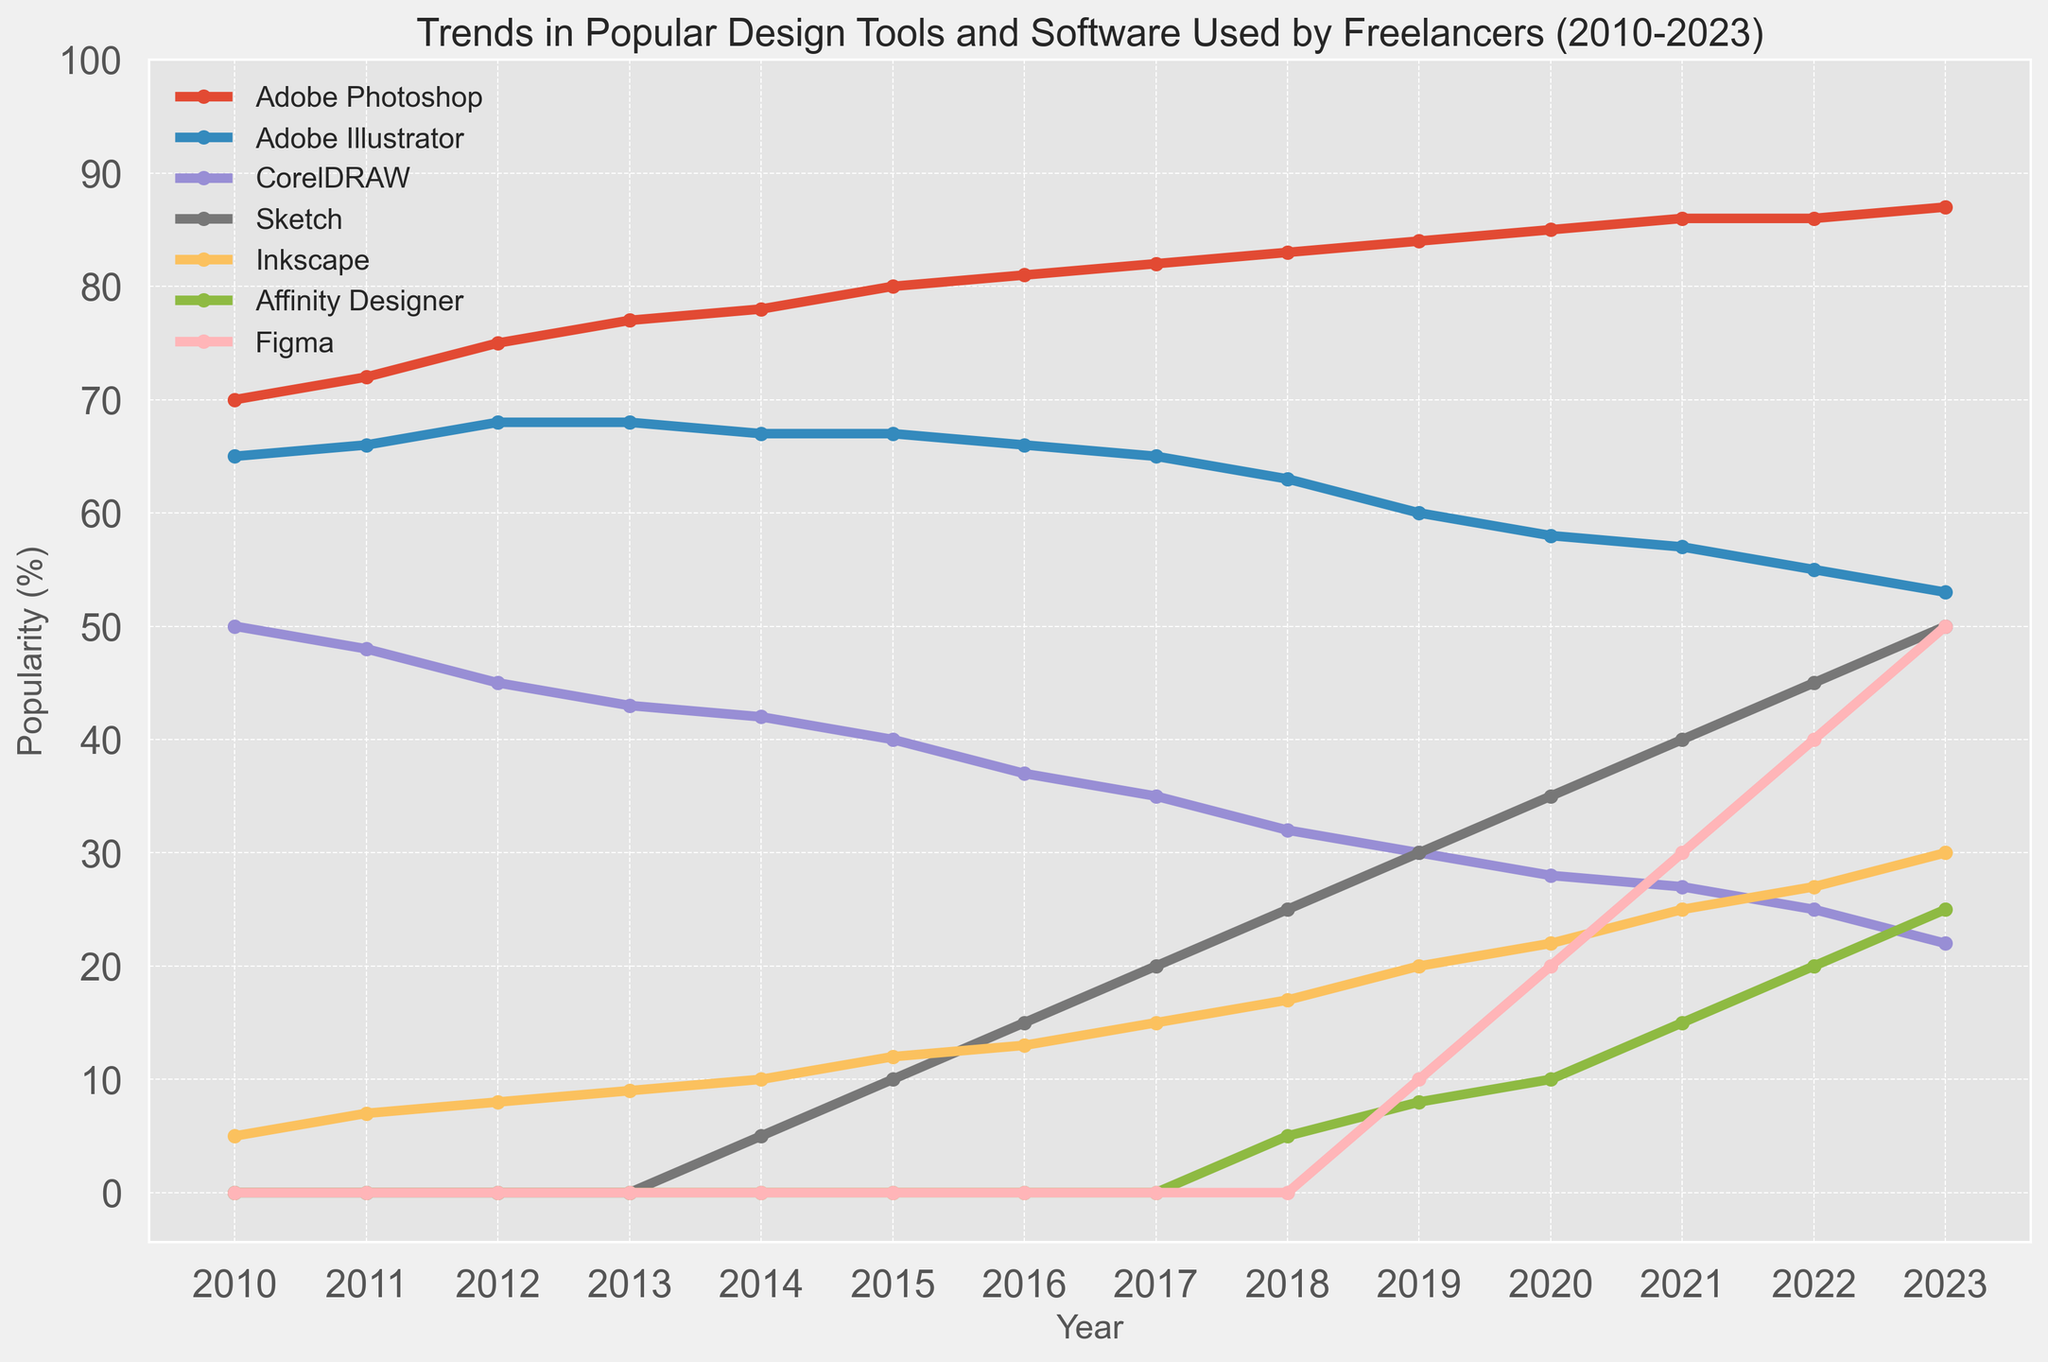What trend can be observed for Adobe Photoshop from 2010 to 2023? By looking at the line corresponding to Adobe Photoshop, we can observe that its popularity increased from 70% in 2010 to 87% in 2023. The trend shows a steady increase over the years.
Answer: Increasing trend Which design tool surpassed 50% popularity first, Sketch or Figma? By following the lines for Sketch and Figma, we see that Sketch reached 50% popularity in 2023, while Figma also reached the 50% mark in 2023. Thus, both surpassed 50% at the same time.
Answer: Both in 2023 How does the popularity of CorelDRAW compare to that of Adobe Illustrator in 2023? In the figure, we observe that the popularity of CorelDRAW in 2023 is at 22%, while Adobe Illustrator is at 53%. Adobe Illustrator is more popular in 2023.
Answer: Adobe Illustrator is more popular What is the overall trend for Inkscape from 2010 to 2023? Examining the line for Inkscape, it starts at 5% in 2010 and increases to 30% in 2023. This shows a rising trend in the use of Inkscape over the given years.
Answer: Increasing trend Which tool had the highest growth in popularity between 2010 and 2023? By comparing the initial and final values for each tool, we can calculate the increase. Figma, growing from 0% in 2010 to 50% in 2023, had the highest growth of 50 percentage points.
Answer: Figma Compare the growth rates of Sketch and Affinity Designer from 2014 to 2023. From 2014 to 2023, Sketch increased from 5% to 50%, a growth of 45 points. Affinity Designer increased from 0% to 25%, a growth of 25 points. Sketch had a higher growth rate.
Answer: Sketch had a higher growth rate Which tool’s popularity decreased the most between 2010 and 2023? Calculation of decrease: Adobe Photoshop (17 point increase), Adobe Illustrator (12 point decrease), CorelDRAW (28 point decrease), Sketch (50 point increase), Inkscape (25 point increase), Affinity Designer (25 point increase), Figma (50 point increase). CorelDRAW decreased by 28 percentage points, the most significant decrease.
Answer: CorelDRAW What is the combined popularity of Adobe Photoshop and Figma in 2020? From the figure, Adobe Photoshop's popularity in 2020 is 85% and Figma's is 20%. Summing these gives 85% + 20% = 105%.
Answer: 105% Which year did Affinity Designer first achieve more than 20% popularity? By examining the Affinity Designer line, we see it surpasses 20% in 2022.
Answer: 2022 How do the trends of Sketch and Figma compare from 2010 to 2023? Sketch starts at 0% in 2010 and rises to 50% in 2023, showing a consistent increase after 2014. Figma also starts at 0% in 2010 and rises to 50% by 2023 but begins its notable rise around 2018. Both tools show steep increases, though Figma's rise is more recent compared to Sketch.
Answer: Both show increasing trends, Figma's rise is more recent 